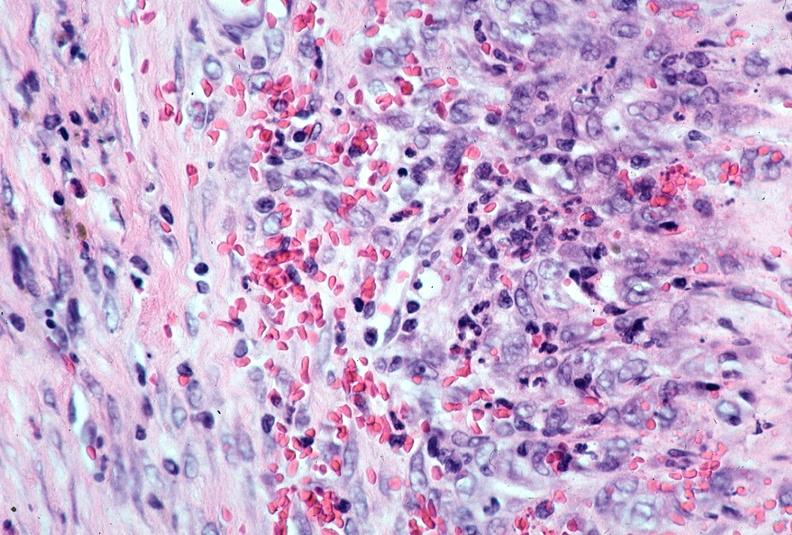s this photo of infant from head to toe present?
Answer the question using a single word or phrase. No 